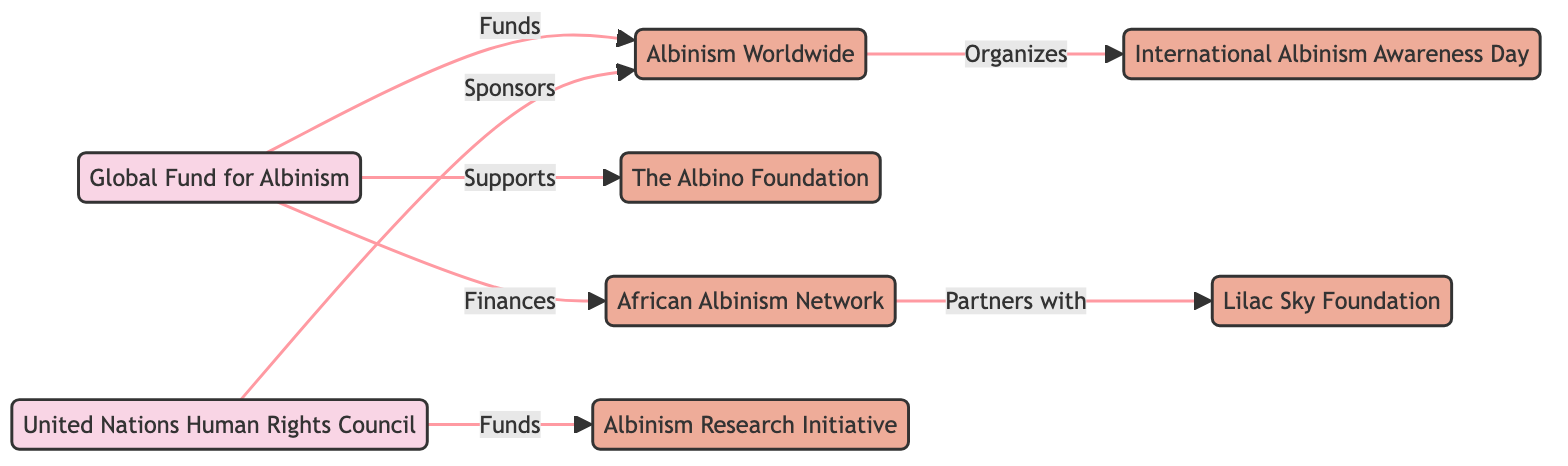What are the funding sources in the diagram? The funding sources are represented by nodes that provide financial support. Looking at the diagram, the sources identified are "Global Fund for Albinism" and "United Nations Human Rights Council".
Answer: Global Fund for Albinism, United Nations Human Rights Council How many recipient organizations are there? By counting the nodes that represent recipient organizations, we find "Albinism Worldwide", "The Albino Foundation", "African Albinism Network", "Albinism Research Initiative", "Lilac Sky Foundation", and "International Albinism Awareness Day", totaling 6 recipient organizations.
Answer: 6 Which organization is organized by "Albinism Worldwide"? Following the directed edge from "Albinism Worldwide", we can see that it organizes "International Albinism Awareness Day".
Answer: International Albinism Awareness Day What relationship does "Global Fund for Albinism" have with "The Albino Foundation"? The edge indicates that "Global Fund for Albinism" supports "The Albino Foundation".
Answer: Supports Which two organizations does "United Nations Human Rights Council" fund? The directed graph shows that "United Nations Human Rights Council" funds "Albinism Worldwide" and "Albinism Research Initiative". By following the directed edges from node 4, we identify these two nodes.
Answer: Albinism Worldwide, Albinism Research Initiative How many total edges are there in this directed graph? By counting all the edges present in the diagram, we find that there are 7 edges displayed, indicating the relationships and funding flows between the nodes.
Answer: 7 What is the direction of funding from "African Albinism Network"? "African Albinism Network" has a directed edge leading to "Lilac Sky Foundation", indicating a partnership or support.
Answer: Partners with 